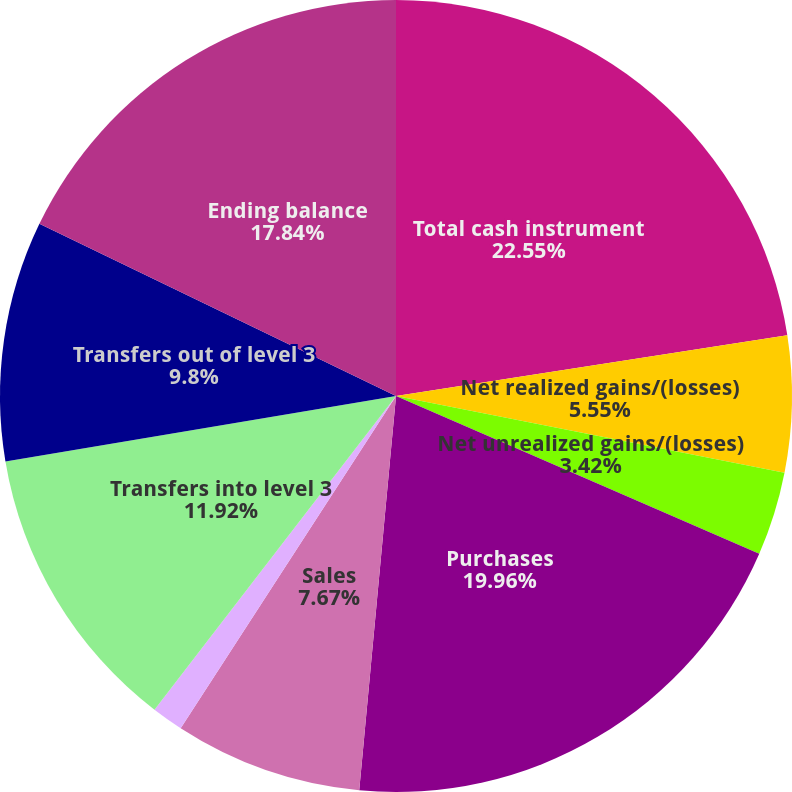Convert chart to OTSL. <chart><loc_0><loc_0><loc_500><loc_500><pie_chart><fcel>Total cash instrument<fcel>Net realized gains/(losses)<fcel>Net unrealized gains/(losses)<fcel>Purchases<fcel>Sales<fcel>Settlements<fcel>Transfers into level 3<fcel>Transfers out of level 3<fcel>Ending balance<nl><fcel>22.55%<fcel>5.55%<fcel>3.42%<fcel>19.96%<fcel>7.67%<fcel>1.29%<fcel>11.92%<fcel>9.8%<fcel>17.84%<nl></chart> 